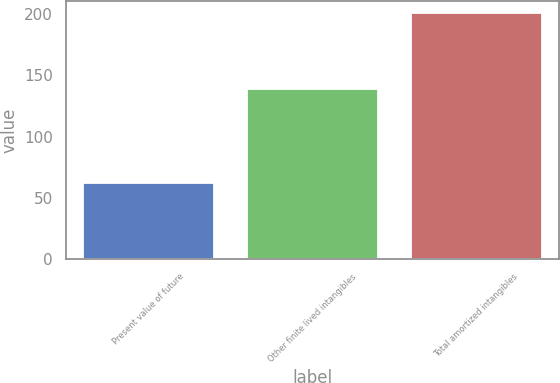Convert chart to OTSL. <chart><loc_0><loc_0><loc_500><loc_500><bar_chart><fcel>Present value of future<fcel>Other finite lived intangibles<fcel>Total amortized intangibles<nl><fcel>62.2<fcel>138.7<fcel>200.9<nl></chart> 